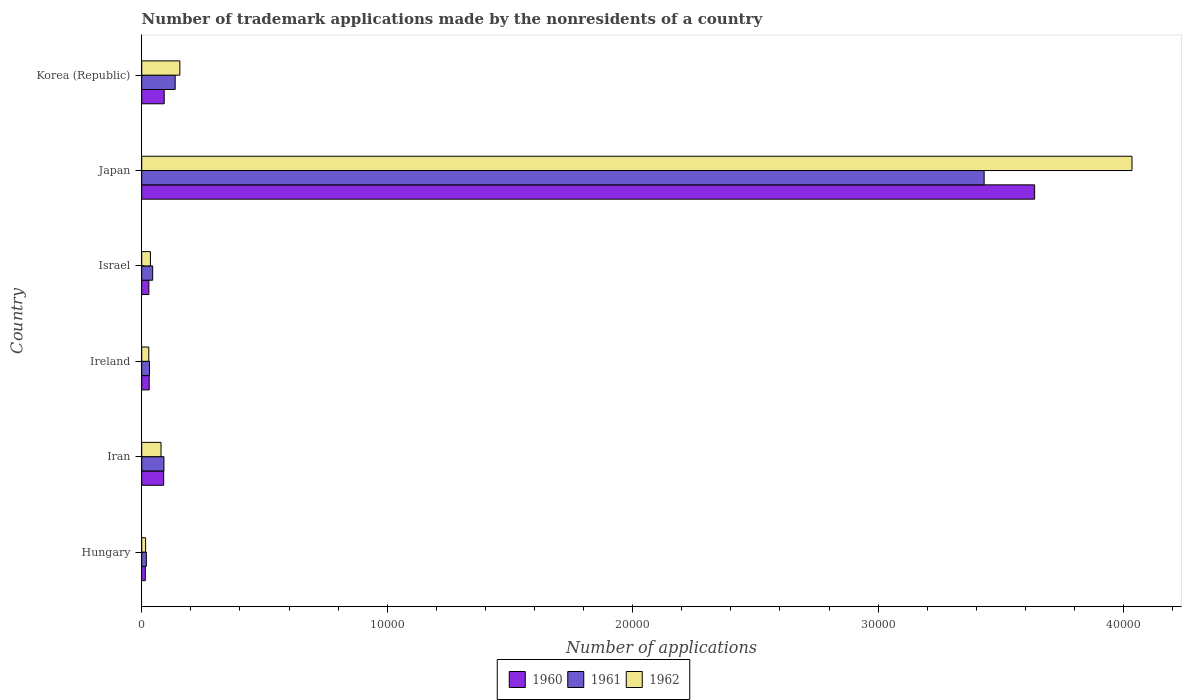How many bars are there on the 5th tick from the bottom?
Offer a terse response. 3. What is the label of the 2nd group of bars from the top?
Ensure brevity in your answer.  Japan. In how many cases, is the number of bars for a given country not equal to the number of legend labels?
Offer a very short reply. 0. What is the number of trademark applications made by the nonresidents in 1962 in Ireland?
Offer a very short reply. 288. Across all countries, what is the maximum number of trademark applications made by the nonresidents in 1960?
Your answer should be very brief. 3.64e+04. Across all countries, what is the minimum number of trademark applications made by the nonresidents in 1960?
Make the answer very short. 147. In which country was the number of trademark applications made by the nonresidents in 1962 maximum?
Provide a short and direct response. Japan. In which country was the number of trademark applications made by the nonresidents in 1961 minimum?
Your answer should be very brief. Hungary. What is the total number of trademark applications made by the nonresidents in 1960 in the graph?
Provide a succinct answer. 3.89e+04. What is the difference between the number of trademark applications made by the nonresidents in 1961 in Iran and that in Ireland?
Provide a succinct answer. 589. What is the difference between the number of trademark applications made by the nonresidents in 1962 in Ireland and the number of trademark applications made by the nonresidents in 1960 in Iran?
Offer a very short reply. -607. What is the average number of trademark applications made by the nonresidents in 1962 per country?
Keep it short and to the point. 7247.33. What is the difference between the number of trademark applications made by the nonresidents in 1962 and number of trademark applications made by the nonresidents in 1960 in Korea (Republic)?
Offer a very short reply. 638. What is the ratio of the number of trademark applications made by the nonresidents in 1961 in Ireland to that in Israel?
Your answer should be compact. 0.71. Is the number of trademark applications made by the nonresidents in 1962 in Israel less than that in Korea (Republic)?
Make the answer very short. Yes. Is the difference between the number of trademark applications made by the nonresidents in 1962 in Hungary and Japan greater than the difference between the number of trademark applications made by the nonresidents in 1960 in Hungary and Japan?
Keep it short and to the point. No. What is the difference between the highest and the second highest number of trademark applications made by the nonresidents in 1962?
Make the answer very short. 3.88e+04. What is the difference between the highest and the lowest number of trademark applications made by the nonresidents in 1962?
Your answer should be compact. 4.02e+04. Is the sum of the number of trademark applications made by the nonresidents in 1960 in Japan and Korea (Republic) greater than the maximum number of trademark applications made by the nonresidents in 1961 across all countries?
Your answer should be compact. Yes. What does the 1st bar from the bottom in Ireland represents?
Offer a terse response. 1960. How many bars are there?
Your response must be concise. 18. Are all the bars in the graph horizontal?
Your response must be concise. Yes. Are the values on the major ticks of X-axis written in scientific E-notation?
Provide a succinct answer. No. Does the graph contain any zero values?
Ensure brevity in your answer.  No. Does the graph contain grids?
Ensure brevity in your answer.  No. How many legend labels are there?
Offer a very short reply. 3. What is the title of the graph?
Provide a short and direct response. Number of trademark applications made by the nonresidents of a country. Does "1983" appear as one of the legend labels in the graph?
Make the answer very short. No. What is the label or title of the X-axis?
Ensure brevity in your answer.  Number of applications. What is the label or title of the Y-axis?
Offer a very short reply. Country. What is the Number of applications in 1960 in Hungary?
Give a very brief answer. 147. What is the Number of applications of 1961 in Hungary?
Your answer should be very brief. 188. What is the Number of applications of 1962 in Hungary?
Keep it short and to the point. 158. What is the Number of applications in 1960 in Iran?
Provide a short and direct response. 895. What is the Number of applications of 1961 in Iran?
Give a very brief answer. 905. What is the Number of applications of 1962 in Iran?
Ensure brevity in your answer.  786. What is the Number of applications in 1960 in Ireland?
Your answer should be compact. 305. What is the Number of applications of 1961 in Ireland?
Provide a succinct answer. 316. What is the Number of applications of 1962 in Ireland?
Provide a succinct answer. 288. What is the Number of applications of 1960 in Israel?
Your answer should be compact. 290. What is the Number of applications in 1961 in Israel?
Make the answer very short. 446. What is the Number of applications in 1962 in Israel?
Provide a succinct answer. 355. What is the Number of applications in 1960 in Japan?
Your answer should be compact. 3.64e+04. What is the Number of applications in 1961 in Japan?
Provide a short and direct response. 3.43e+04. What is the Number of applications of 1962 in Japan?
Your answer should be compact. 4.03e+04. What is the Number of applications in 1960 in Korea (Republic)?
Make the answer very short. 916. What is the Number of applications of 1961 in Korea (Republic)?
Provide a succinct answer. 1363. What is the Number of applications in 1962 in Korea (Republic)?
Keep it short and to the point. 1554. Across all countries, what is the maximum Number of applications in 1960?
Your response must be concise. 3.64e+04. Across all countries, what is the maximum Number of applications in 1961?
Your answer should be compact. 3.43e+04. Across all countries, what is the maximum Number of applications of 1962?
Your response must be concise. 4.03e+04. Across all countries, what is the minimum Number of applications of 1960?
Provide a short and direct response. 147. Across all countries, what is the minimum Number of applications in 1961?
Make the answer very short. 188. Across all countries, what is the minimum Number of applications in 1962?
Keep it short and to the point. 158. What is the total Number of applications in 1960 in the graph?
Make the answer very short. 3.89e+04. What is the total Number of applications in 1961 in the graph?
Ensure brevity in your answer.  3.75e+04. What is the total Number of applications of 1962 in the graph?
Make the answer very short. 4.35e+04. What is the difference between the Number of applications of 1960 in Hungary and that in Iran?
Give a very brief answer. -748. What is the difference between the Number of applications of 1961 in Hungary and that in Iran?
Offer a terse response. -717. What is the difference between the Number of applications of 1962 in Hungary and that in Iran?
Offer a terse response. -628. What is the difference between the Number of applications of 1960 in Hungary and that in Ireland?
Offer a very short reply. -158. What is the difference between the Number of applications in 1961 in Hungary and that in Ireland?
Your response must be concise. -128. What is the difference between the Number of applications of 1962 in Hungary and that in Ireland?
Keep it short and to the point. -130. What is the difference between the Number of applications in 1960 in Hungary and that in Israel?
Ensure brevity in your answer.  -143. What is the difference between the Number of applications of 1961 in Hungary and that in Israel?
Keep it short and to the point. -258. What is the difference between the Number of applications in 1962 in Hungary and that in Israel?
Provide a succinct answer. -197. What is the difference between the Number of applications in 1960 in Hungary and that in Japan?
Your response must be concise. -3.62e+04. What is the difference between the Number of applications of 1961 in Hungary and that in Japan?
Provide a succinct answer. -3.41e+04. What is the difference between the Number of applications in 1962 in Hungary and that in Japan?
Your response must be concise. -4.02e+04. What is the difference between the Number of applications in 1960 in Hungary and that in Korea (Republic)?
Provide a succinct answer. -769. What is the difference between the Number of applications in 1961 in Hungary and that in Korea (Republic)?
Your answer should be compact. -1175. What is the difference between the Number of applications in 1962 in Hungary and that in Korea (Republic)?
Offer a terse response. -1396. What is the difference between the Number of applications in 1960 in Iran and that in Ireland?
Offer a terse response. 590. What is the difference between the Number of applications of 1961 in Iran and that in Ireland?
Keep it short and to the point. 589. What is the difference between the Number of applications in 1962 in Iran and that in Ireland?
Provide a succinct answer. 498. What is the difference between the Number of applications of 1960 in Iran and that in Israel?
Offer a terse response. 605. What is the difference between the Number of applications in 1961 in Iran and that in Israel?
Give a very brief answer. 459. What is the difference between the Number of applications of 1962 in Iran and that in Israel?
Provide a succinct answer. 431. What is the difference between the Number of applications of 1960 in Iran and that in Japan?
Offer a terse response. -3.55e+04. What is the difference between the Number of applications in 1961 in Iran and that in Japan?
Your answer should be compact. -3.34e+04. What is the difference between the Number of applications in 1962 in Iran and that in Japan?
Keep it short and to the point. -3.96e+04. What is the difference between the Number of applications in 1960 in Iran and that in Korea (Republic)?
Give a very brief answer. -21. What is the difference between the Number of applications of 1961 in Iran and that in Korea (Republic)?
Offer a terse response. -458. What is the difference between the Number of applications of 1962 in Iran and that in Korea (Republic)?
Provide a short and direct response. -768. What is the difference between the Number of applications of 1961 in Ireland and that in Israel?
Your answer should be very brief. -130. What is the difference between the Number of applications of 1962 in Ireland and that in Israel?
Give a very brief answer. -67. What is the difference between the Number of applications of 1960 in Ireland and that in Japan?
Your answer should be very brief. -3.61e+04. What is the difference between the Number of applications of 1961 in Ireland and that in Japan?
Provide a short and direct response. -3.40e+04. What is the difference between the Number of applications in 1962 in Ireland and that in Japan?
Provide a succinct answer. -4.01e+04. What is the difference between the Number of applications of 1960 in Ireland and that in Korea (Republic)?
Keep it short and to the point. -611. What is the difference between the Number of applications in 1961 in Ireland and that in Korea (Republic)?
Your answer should be very brief. -1047. What is the difference between the Number of applications in 1962 in Ireland and that in Korea (Republic)?
Keep it short and to the point. -1266. What is the difference between the Number of applications in 1960 in Israel and that in Japan?
Offer a very short reply. -3.61e+04. What is the difference between the Number of applications in 1961 in Israel and that in Japan?
Offer a terse response. -3.39e+04. What is the difference between the Number of applications of 1962 in Israel and that in Japan?
Make the answer very short. -4.00e+04. What is the difference between the Number of applications in 1960 in Israel and that in Korea (Republic)?
Make the answer very short. -626. What is the difference between the Number of applications in 1961 in Israel and that in Korea (Republic)?
Provide a short and direct response. -917. What is the difference between the Number of applications of 1962 in Israel and that in Korea (Republic)?
Provide a short and direct response. -1199. What is the difference between the Number of applications of 1960 in Japan and that in Korea (Republic)?
Keep it short and to the point. 3.55e+04. What is the difference between the Number of applications in 1961 in Japan and that in Korea (Republic)?
Your answer should be compact. 3.30e+04. What is the difference between the Number of applications of 1962 in Japan and that in Korea (Republic)?
Offer a terse response. 3.88e+04. What is the difference between the Number of applications in 1960 in Hungary and the Number of applications in 1961 in Iran?
Ensure brevity in your answer.  -758. What is the difference between the Number of applications of 1960 in Hungary and the Number of applications of 1962 in Iran?
Ensure brevity in your answer.  -639. What is the difference between the Number of applications of 1961 in Hungary and the Number of applications of 1962 in Iran?
Offer a terse response. -598. What is the difference between the Number of applications of 1960 in Hungary and the Number of applications of 1961 in Ireland?
Offer a very short reply. -169. What is the difference between the Number of applications of 1960 in Hungary and the Number of applications of 1962 in Ireland?
Your answer should be very brief. -141. What is the difference between the Number of applications of 1961 in Hungary and the Number of applications of 1962 in Ireland?
Ensure brevity in your answer.  -100. What is the difference between the Number of applications in 1960 in Hungary and the Number of applications in 1961 in Israel?
Ensure brevity in your answer.  -299. What is the difference between the Number of applications of 1960 in Hungary and the Number of applications of 1962 in Israel?
Offer a very short reply. -208. What is the difference between the Number of applications in 1961 in Hungary and the Number of applications in 1962 in Israel?
Your answer should be compact. -167. What is the difference between the Number of applications of 1960 in Hungary and the Number of applications of 1961 in Japan?
Offer a terse response. -3.42e+04. What is the difference between the Number of applications in 1960 in Hungary and the Number of applications in 1962 in Japan?
Provide a short and direct response. -4.02e+04. What is the difference between the Number of applications in 1961 in Hungary and the Number of applications in 1962 in Japan?
Keep it short and to the point. -4.02e+04. What is the difference between the Number of applications of 1960 in Hungary and the Number of applications of 1961 in Korea (Republic)?
Your answer should be compact. -1216. What is the difference between the Number of applications in 1960 in Hungary and the Number of applications in 1962 in Korea (Republic)?
Provide a short and direct response. -1407. What is the difference between the Number of applications of 1961 in Hungary and the Number of applications of 1962 in Korea (Republic)?
Keep it short and to the point. -1366. What is the difference between the Number of applications of 1960 in Iran and the Number of applications of 1961 in Ireland?
Keep it short and to the point. 579. What is the difference between the Number of applications in 1960 in Iran and the Number of applications in 1962 in Ireland?
Ensure brevity in your answer.  607. What is the difference between the Number of applications of 1961 in Iran and the Number of applications of 1962 in Ireland?
Provide a short and direct response. 617. What is the difference between the Number of applications of 1960 in Iran and the Number of applications of 1961 in Israel?
Offer a very short reply. 449. What is the difference between the Number of applications of 1960 in Iran and the Number of applications of 1962 in Israel?
Ensure brevity in your answer.  540. What is the difference between the Number of applications in 1961 in Iran and the Number of applications in 1962 in Israel?
Your response must be concise. 550. What is the difference between the Number of applications in 1960 in Iran and the Number of applications in 1961 in Japan?
Your answer should be compact. -3.34e+04. What is the difference between the Number of applications of 1960 in Iran and the Number of applications of 1962 in Japan?
Your response must be concise. -3.94e+04. What is the difference between the Number of applications of 1961 in Iran and the Number of applications of 1962 in Japan?
Your answer should be very brief. -3.94e+04. What is the difference between the Number of applications in 1960 in Iran and the Number of applications in 1961 in Korea (Republic)?
Make the answer very short. -468. What is the difference between the Number of applications in 1960 in Iran and the Number of applications in 1962 in Korea (Republic)?
Your answer should be compact. -659. What is the difference between the Number of applications of 1961 in Iran and the Number of applications of 1962 in Korea (Republic)?
Offer a terse response. -649. What is the difference between the Number of applications of 1960 in Ireland and the Number of applications of 1961 in Israel?
Give a very brief answer. -141. What is the difference between the Number of applications of 1960 in Ireland and the Number of applications of 1962 in Israel?
Your answer should be very brief. -50. What is the difference between the Number of applications in 1961 in Ireland and the Number of applications in 1962 in Israel?
Keep it short and to the point. -39. What is the difference between the Number of applications of 1960 in Ireland and the Number of applications of 1961 in Japan?
Provide a succinct answer. -3.40e+04. What is the difference between the Number of applications of 1960 in Ireland and the Number of applications of 1962 in Japan?
Give a very brief answer. -4.00e+04. What is the difference between the Number of applications in 1961 in Ireland and the Number of applications in 1962 in Japan?
Your answer should be compact. -4.00e+04. What is the difference between the Number of applications of 1960 in Ireland and the Number of applications of 1961 in Korea (Republic)?
Your response must be concise. -1058. What is the difference between the Number of applications in 1960 in Ireland and the Number of applications in 1962 in Korea (Republic)?
Offer a very short reply. -1249. What is the difference between the Number of applications of 1961 in Ireland and the Number of applications of 1962 in Korea (Republic)?
Your answer should be compact. -1238. What is the difference between the Number of applications of 1960 in Israel and the Number of applications of 1961 in Japan?
Make the answer very short. -3.40e+04. What is the difference between the Number of applications of 1960 in Israel and the Number of applications of 1962 in Japan?
Your answer should be compact. -4.01e+04. What is the difference between the Number of applications of 1961 in Israel and the Number of applications of 1962 in Japan?
Provide a succinct answer. -3.99e+04. What is the difference between the Number of applications in 1960 in Israel and the Number of applications in 1961 in Korea (Republic)?
Ensure brevity in your answer.  -1073. What is the difference between the Number of applications of 1960 in Israel and the Number of applications of 1962 in Korea (Republic)?
Your answer should be very brief. -1264. What is the difference between the Number of applications in 1961 in Israel and the Number of applications in 1962 in Korea (Republic)?
Ensure brevity in your answer.  -1108. What is the difference between the Number of applications of 1960 in Japan and the Number of applications of 1961 in Korea (Republic)?
Give a very brief answer. 3.50e+04. What is the difference between the Number of applications of 1960 in Japan and the Number of applications of 1962 in Korea (Republic)?
Offer a very short reply. 3.48e+04. What is the difference between the Number of applications of 1961 in Japan and the Number of applications of 1962 in Korea (Republic)?
Make the answer very short. 3.28e+04. What is the average Number of applications in 1960 per country?
Provide a short and direct response. 6488.33. What is the average Number of applications in 1961 per country?
Offer a terse response. 6256.33. What is the average Number of applications in 1962 per country?
Your answer should be very brief. 7247.33. What is the difference between the Number of applications in 1960 and Number of applications in 1961 in Hungary?
Provide a short and direct response. -41. What is the difference between the Number of applications of 1960 and Number of applications of 1962 in Hungary?
Provide a succinct answer. -11. What is the difference between the Number of applications of 1961 and Number of applications of 1962 in Hungary?
Offer a very short reply. 30. What is the difference between the Number of applications in 1960 and Number of applications in 1961 in Iran?
Your answer should be very brief. -10. What is the difference between the Number of applications of 1960 and Number of applications of 1962 in Iran?
Make the answer very short. 109. What is the difference between the Number of applications of 1961 and Number of applications of 1962 in Iran?
Your answer should be very brief. 119. What is the difference between the Number of applications of 1961 and Number of applications of 1962 in Ireland?
Provide a succinct answer. 28. What is the difference between the Number of applications of 1960 and Number of applications of 1961 in Israel?
Your answer should be compact. -156. What is the difference between the Number of applications in 1960 and Number of applications in 1962 in Israel?
Offer a very short reply. -65. What is the difference between the Number of applications in 1961 and Number of applications in 1962 in Israel?
Offer a terse response. 91. What is the difference between the Number of applications in 1960 and Number of applications in 1961 in Japan?
Your answer should be very brief. 2057. What is the difference between the Number of applications of 1960 and Number of applications of 1962 in Japan?
Make the answer very short. -3966. What is the difference between the Number of applications in 1961 and Number of applications in 1962 in Japan?
Ensure brevity in your answer.  -6023. What is the difference between the Number of applications in 1960 and Number of applications in 1961 in Korea (Republic)?
Give a very brief answer. -447. What is the difference between the Number of applications of 1960 and Number of applications of 1962 in Korea (Republic)?
Your response must be concise. -638. What is the difference between the Number of applications of 1961 and Number of applications of 1962 in Korea (Republic)?
Offer a very short reply. -191. What is the ratio of the Number of applications in 1960 in Hungary to that in Iran?
Keep it short and to the point. 0.16. What is the ratio of the Number of applications in 1961 in Hungary to that in Iran?
Offer a very short reply. 0.21. What is the ratio of the Number of applications in 1962 in Hungary to that in Iran?
Provide a succinct answer. 0.2. What is the ratio of the Number of applications in 1960 in Hungary to that in Ireland?
Keep it short and to the point. 0.48. What is the ratio of the Number of applications of 1961 in Hungary to that in Ireland?
Keep it short and to the point. 0.59. What is the ratio of the Number of applications in 1962 in Hungary to that in Ireland?
Provide a short and direct response. 0.55. What is the ratio of the Number of applications of 1960 in Hungary to that in Israel?
Provide a succinct answer. 0.51. What is the ratio of the Number of applications of 1961 in Hungary to that in Israel?
Provide a short and direct response. 0.42. What is the ratio of the Number of applications in 1962 in Hungary to that in Israel?
Keep it short and to the point. 0.45. What is the ratio of the Number of applications in 1960 in Hungary to that in Japan?
Your response must be concise. 0. What is the ratio of the Number of applications in 1961 in Hungary to that in Japan?
Your answer should be compact. 0.01. What is the ratio of the Number of applications of 1962 in Hungary to that in Japan?
Ensure brevity in your answer.  0. What is the ratio of the Number of applications in 1960 in Hungary to that in Korea (Republic)?
Your answer should be compact. 0.16. What is the ratio of the Number of applications of 1961 in Hungary to that in Korea (Republic)?
Your answer should be very brief. 0.14. What is the ratio of the Number of applications of 1962 in Hungary to that in Korea (Republic)?
Make the answer very short. 0.1. What is the ratio of the Number of applications of 1960 in Iran to that in Ireland?
Your answer should be very brief. 2.93. What is the ratio of the Number of applications in 1961 in Iran to that in Ireland?
Give a very brief answer. 2.86. What is the ratio of the Number of applications of 1962 in Iran to that in Ireland?
Your answer should be compact. 2.73. What is the ratio of the Number of applications of 1960 in Iran to that in Israel?
Your response must be concise. 3.09. What is the ratio of the Number of applications in 1961 in Iran to that in Israel?
Keep it short and to the point. 2.03. What is the ratio of the Number of applications of 1962 in Iran to that in Israel?
Give a very brief answer. 2.21. What is the ratio of the Number of applications of 1960 in Iran to that in Japan?
Provide a short and direct response. 0.02. What is the ratio of the Number of applications of 1961 in Iran to that in Japan?
Provide a short and direct response. 0.03. What is the ratio of the Number of applications in 1962 in Iran to that in Japan?
Your answer should be compact. 0.02. What is the ratio of the Number of applications of 1960 in Iran to that in Korea (Republic)?
Keep it short and to the point. 0.98. What is the ratio of the Number of applications of 1961 in Iran to that in Korea (Republic)?
Offer a terse response. 0.66. What is the ratio of the Number of applications of 1962 in Iran to that in Korea (Republic)?
Offer a very short reply. 0.51. What is the ratio of the Number of applications of 1960 in Ireland to that in Israel?
Keep it short and to the point. 1.05. What is the ratio of the Number of applications in 1961 in Ireland to that in Israel?
Your response must be concise. 0.71. What is the ratio of the Number of applications of 1962 in Ireland to that in Israel?
Keep it short and to the point. 0.81. What is the ratio of the Number of applications in 1960 in Ireland to that in Japan?
Your answer should be compact. 0.01. What is the ratio of the Number of applications of 1961 in Ireland to that in Japan?
Provide a succinct answer. 0.01. What is the ratio of the Number of applications of 1962 in Ireland to that in Japan?
Make the answer very short. 0.01. What is the ratio of the Number of applications of 1960 in Ireland to that in Korea (Republic)?
Make the answer very short. 0.33. What is the ratio of the Number of applications in 1961 in Ireland to that in Korea (Republic)?
Your response must be concise. 0.23. What is the ratio of the Number of applications of 1962 in Ireland to that in Korea (Republic)?
Make the answer very short. 0.19. What is the ratio of the Number of applications of 1960 in Israel to that in Japan?
Offer a very short reply. 0.01. What is the ratio of the Number of applications in 1961 in Israel to that in Japan?
Offer a terse response. 0.01. What is the ratio of the Number of applications of 1962 in Israel to that in Japan?
Your answer should be very brief. 0.01. What is the ratio of the Number of applications of 1960 in Israel to that in Korea (Republic)?
Provide a short and direct response. 0.32. What is the ratio of the Number of applications in 1961 in Israel to that in Korea (Republic)?
Provide a succinct answer. 0.33. What is the ratio of the Number of applications in 1962 in Israel to that in Korea (Republic)?
Ensure brevity in your answer.  0.23. What is the ratio of the Number of applications in 1960 in Japan to that in Korea (Republic)?
Your response must be concise. 39.71. What is the ratio of the Number of applications of 1961 in Japan to that in Korea (Republic)?
Your response must be concise. 25.18. What is the ratio of the Number of applications in 1962 in Japan to that in Korea (Republic)?
Your response must be concise. 25.96. What is the difference between the highest and the second highest Number of applications in 1960?
Keep it short and to the point. 3.55e+04. What is the difference between the highest and the second highest Number of applications in 1961?
Ensure brevity in your answer.  3.30e+04. What is the difference between the highest and the second highest Number of applications in 1962?
Provide a succinct answer. 3.88e+04. What is the difference between the highest and the lowest Number of applications of 1960?
Your response must be concise. 3.62e+04. What is the difference between the highest and the lowest Number of applications of 1961?
Keep it short and to the point. 3.41e+04. What is the difference between the highest and the lowest Number of applications of 1962?
Offer a terse response. 4.02e+04. 